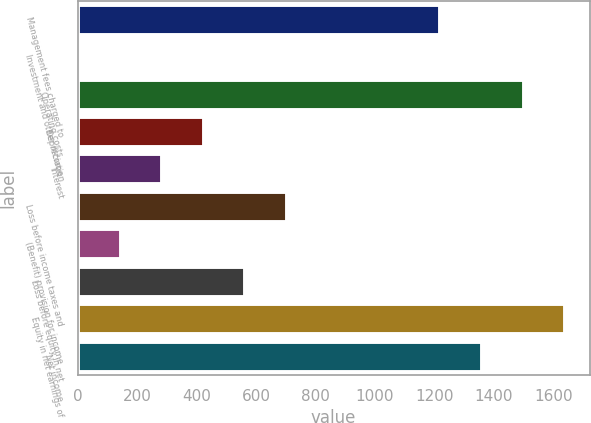Convert chart. <chart><loc_0><loc_0><loc_500><loc_500><bar_chart><fcel>Management fees charged to<fcel>Investment and other income<fcel>Operating costs<fcel>Depreciation<fcel>Interest<fcel>Loss before income taxes and<fcel>(Benefit) provision for income<fcel>Loss before equity in net<fcel>Equity in net earnings of<fcel>Net income<nl><fcel>1220<fcel>5<fcel>1499.4<fcel>424.1<fcel>284.4<fcel>703.5<fcel>144.7<fcel>563.8<fcel>1639.1<fcel>1359.7<nl></chart> 